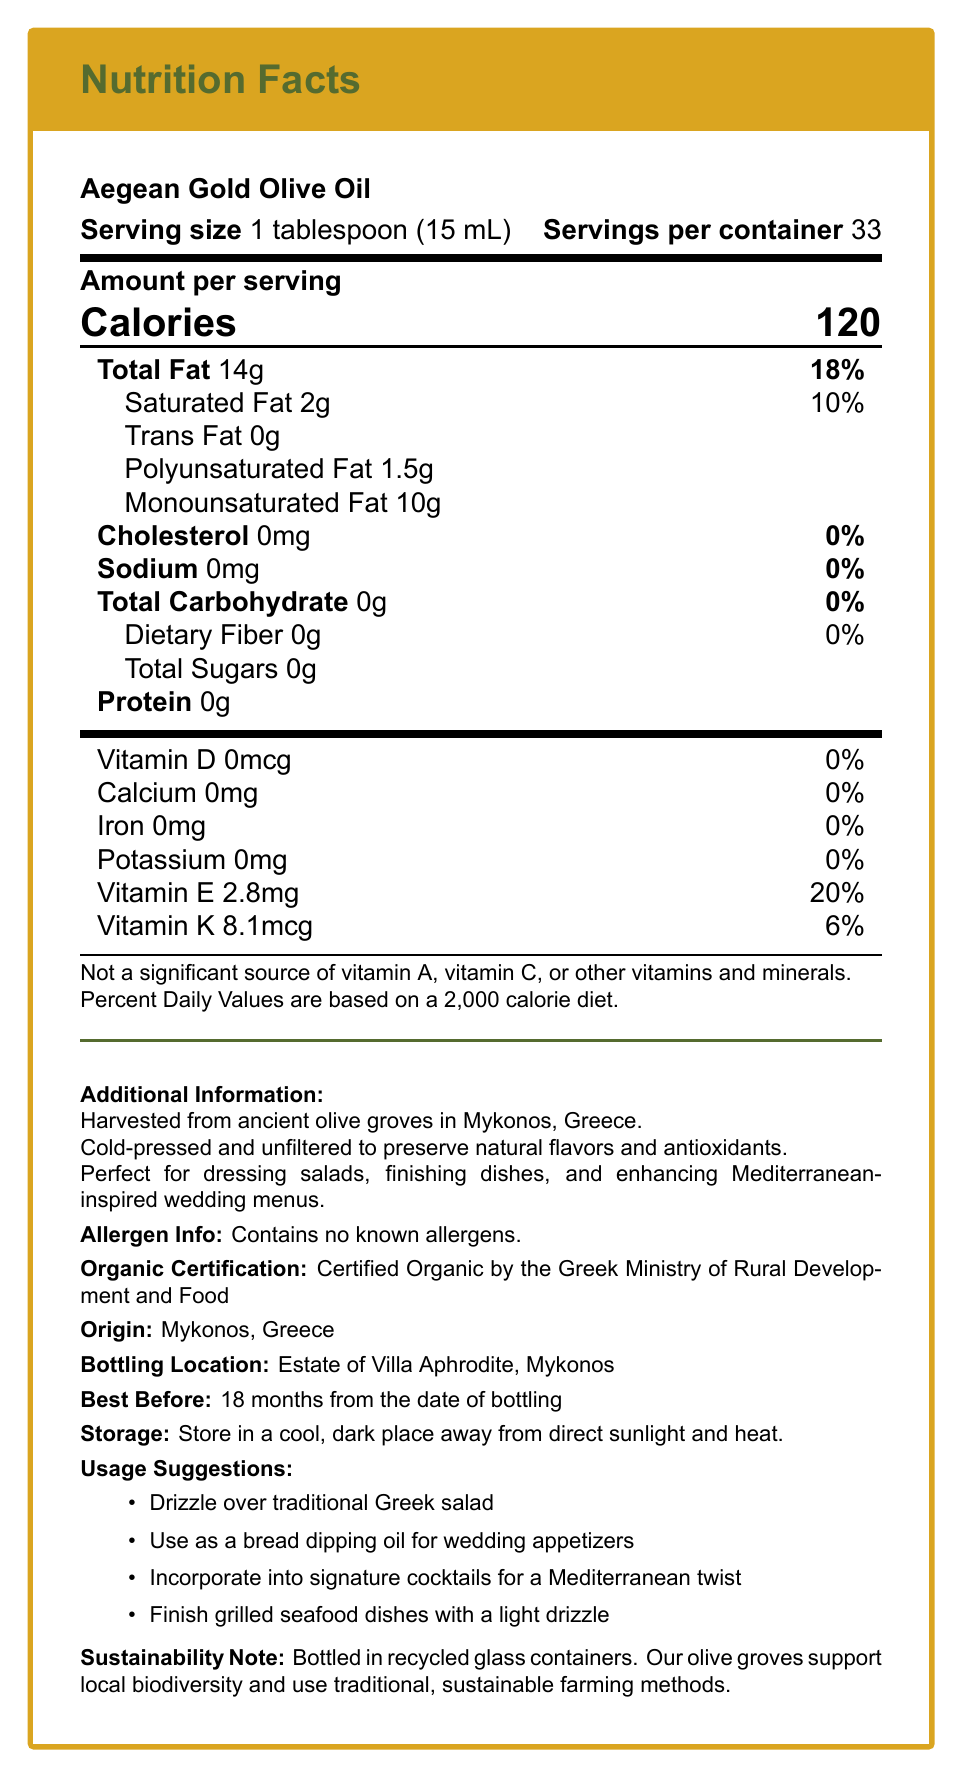what is the serving size of Aegean Gold Olive Oil? The document states the serving size as "1 tablespoon (15 mL)".
Answer: 1 tablespoon (15 mL) how many calories are in one serving? The document states that each serving of the olive oil contains 120 calories.
Answer: 120 calories what percentage of the daily value of total fat does one serving contain? The document shows that one serving contains 18% of the daily value for total fat.
Answer: 18% is there any cholesterol in Aegean Gold Olive Oil? According to the document, the cholesterol content in the olive oil is 0mg.
Answer: No how much vitamin E does one serving provide? The document lists the vitamin E content as 2.8mg per serving.
Answer: 2.8mg what are the multiple uses suggested for the olive oil? A. Drizzle over traditional Greek salad B. Use as a bread dipping oil C. Incorporate into signature cocktails D. All of the above The document provides usage suggestions including drizzling over Greek salad, using as a bread dipping oil, and incorporating into signature cocktails.
Answer: D. All of the above how much saturated fat is in one serving? The document indicates that each serving contains 2g of saturated fat.
Answer: 2g what is the origin of Aegean Gold Olive Oil? The document specifies that the olive oil originates from Mykonos, Greece.
Answer: Mykonos, Greece are there any known allergens in this product? The document states that the olive oil contains no known allergens.
Answer: No which vitamin is not a significant source in this olive oil? A. Vitamin A B. Vitamin C C. Vitamin D D. Vitamin E The document notes that it is not a significant source of vitamins A, C, or other vitamins and minerals.
Answer: A. Vitamin A and B. Vitamin C what is the best before date for this olive oil? The document mentions that the olive oil is best before 18 months from the date of bottling.
Answer: 18 months from the date of bottling how should this olive oil be stored? The document advises storing the olive oil in a cool, dark place away from direct sunlight and heat.
Answer: In a cool, dark place away from direct sunlight and heat does Aegean Gold Olive Oil support local biodiversity? The document states that the olive groves support local biodiversity using traditional, sustainable farming methods.
Answer: Yes is this olive oil certified organic? The document lists that it is certified organic by the Greek Ministry of Rural Development and Food.
Answer: Yes how much trans fat is in one serving? According to the document, the trans fat content is 0g per serving.
Answer: 0g is potassium significantly present in this olive oil? The document shows that the potassium content is 0mg, indicating it is not significantly present.
Answer: No summarize the main idea of the nutrition facts label. This summary compiles the main elements from the nutritional information, additional details, and the premium quality aspects described in the document.
Answer: The nutrition facts label for Aegean Gold Olive Oil provides detailed information on its serving size, nutritional content, vitamins, origin, storage instructions, and usage suggestions. This olive oil is a premium product, harvested from Mykonos, Greece, and is ideal for Mediterranean-inspired dishes, supporting sustainability and local biodiversity. what is the content of dietary fiber in one serving? The document indicates the dietary fiber content as 0g per serving.
Answer: 0g how many milligrams of sodium are in one serving? The document lists the sodium content as 0mg per serving.
Answer: 0mg where is the olive oil bottled? The document specifies the bottling location as Estate of Villa Aphrodite, Mykonos.
Answer: Estate of Villa Aphrodite, Mykonos can this olive oil support a high-protein diet? The document does not provide enough information on the protein content or how well it supports a high-protein diet.
Answer: Not enough information 